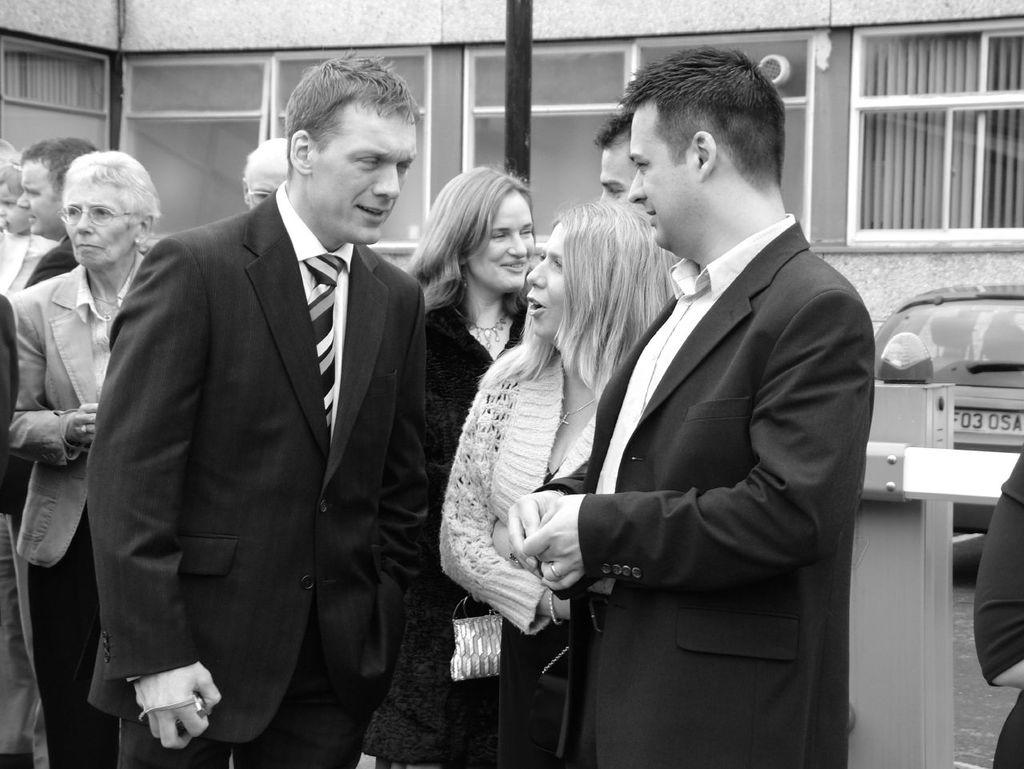What are the people in the image doing? The people in the image are standing. What is the man holding in his hand? The man is holding a camera in his hand. What can be seen in the background of the image? There is a building in the background of the image. What object is present in the image that is typically used for supporting signs or other objects? There is a pole in the image. What type of vehicle can be seen in the image? A car is parked in the image. What type of wax can be seen melting on the birthday cake in the image? There is no birthday cake or wax present in the image. What type of trail can be seen in the image? There is no trail visible in the image. 